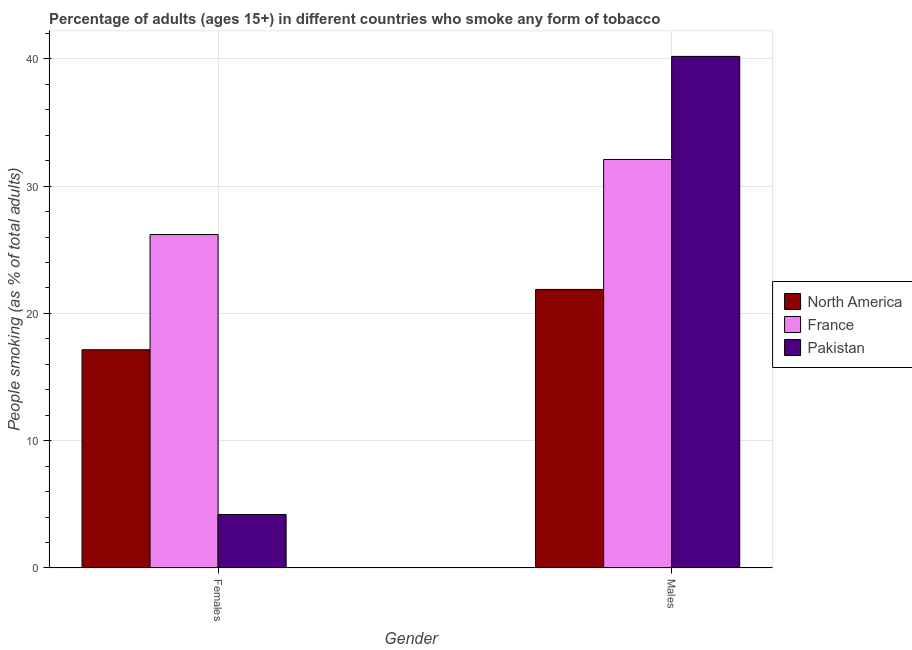How many different coloured bars are there?
Make the answer very short. 3. How many groups of bars are there?
Ensure brevity in your answer.  2. How many bars are there on the 2nd tick from the right?
Provide a succinct answer. 3. What is the label of the 2nd group of bars from the left?
Keep it short and to the point. Males. What is the percentage of males who smoke in Pakistan?
Your response must be concise. 40.2. Across all countries, what is the maximum percentage of females who smoke?
Give a very brief answer. 26.2. Across all countries, what is the minimum percentage of females who smoke?
Make the answer very short. 4.2. In which country was the percentage of males who smoke maximum?
Your response must be concise. Pakistan. In which country was the percentage of females who smoke minimum?
Offer a terse response. Pakistan. What is the total percentage of females who smoke in the graph?
Your answer should be very brief. 47.55. What is the difference between the percentage of males who smoke in France and the percentage of females who smoke in North America?
Offer a terse response. 14.95. What is the average percentage of males who smoke per country?
Give a very brief answer. 31.4. What is the difference between the percentage of females who smoke and percentage of males who smoke in North America?
Your answer should be very brief. -4.74. What is the ratio of the percentage of females who smoke in North America to that in Pakistan?
Give a very brief answer. 4.08. Is the percentage of females who smoke in France less than that in Pakistan?
Your answer should be very brief. No. What does the 1st bar from the left in Males represents?
Keep it short and to the point. North America. Are all the bars in the graph horizontal?
Provide a short and direct response. No. How many countries are there in the graph?
Offer a terse response. 3. Are the values on the major ticks of Y-axis written in scientific E-notation?
Keep it short and to the point. No. Does the graph contain any zero values?
Your response must be concise. No. How are the legend labels stacked?
Your answer should be very brief. Vertical. What is the title of the graph?
Your response must be concise. Percentage of adults (ages 15+) in different countries who smoke any form of tobacco. What is the label or title of the X-axis?
Your answer should be very brief. Gender. What is the label or title of the Y-axis?
Your answer should be very brief. People smoking (as % of total adults). What is the People smoking (as % of total adults) of North America in Females?
Keep it short and to the point. 17.15. What is the People smoking (as % of total adults) in France in Females?
Give a very brief answer. 26.2. What is the People smoking (as % of total adults) of North America in Males?
Keep it short and to the point. 21.89. What is the People smoking (as % of total adults) of France in Males?
Offer a terse response. 32.1. What is the People smoking (as % of total adults) in Pakistan in Males?
Your answer should be compact. 40.2. Across all Gender, what is the maximum People smoking (as % of total adults) of North America?
Give a very brief answer. 21.89. Across all Gender, what is the maximum People smoking (as % of total adults) in France?
Give a very brief answer. 32.1. Across all Gender, what is the maximum People smoking (as % of total adults) of Pakistan?
Ensure brevity in your answer.  40.2. Across all Gender, what is the minimum People smoking (as % of total adults) in North America?
Give a very brief answer. 17.15. Across all Gender, what is the minimum People smoking (as % of total adults) of France?
Offer a very short reply. 26.2. Across all Gender, what is the minimum People smoking (as % of total adults) of Pakistan?
Ensure brevity in your answer.  4.2. What is the total People smoking (as % of total adults) in North America in the graph?
Provide a succinct answer. 39.04. What is the total People smoking (as % of total adults) of France in the graph?
Make the answer very short. 58.3. What is the total People smoking (as % of total adults) of Pakistan in the graph?
Ensure brevity in your answer.  44.4. What is the difference between the People smoking (as % of total adults) of North America in Females and that in Males?
Offer a very short reply. -4.74. What is the difference between the People smoking (as % of total adults) in France in Females and that in Males?
Offer a terse response. -5.9. What is the difference between the People smoking (as % of total adults) in Pakistan in Females and that in Males?
Ensure brevity in your answer.  -36. What is the difference between the People smoking (as % of total adults) of North America in Females and the People smoking (as % of total adults) of France in Males?
Provide a short and direct response. -14.95. What is the difference between the People smoking (as % of total adults) in North America in Females and the People smoking (as % of total adults) in Pakistan in Males?
Offer a terse response. -23.05. What is the difference between the People smoking (as % of total adults) of France in Females and the People smoking (as % of total adults) of Pakistan in Males?
Ensure brevity in your answer.  -14. What is the average People smoking (as % of total adults) in North America per Gender?
Your response must be concise. 19.52. What is the average People smoking (as % of total adults) in France per Gender?
Keep it short and to the point. 29.15. What is the difference between the People smoking (as % of total adults) in North America and People smoking (as % of total adults) in France in Females?
Your answer should be very brief. -9.05. What is the difference between the People smoking (as % of total adults) of North America and People smoking (as % of total adults) of Pakistan in Females?
Make the answer very short. 12.95. What is the difference between the People smoking (as % of total adults) of North America and People smoking (as % of total adults) of France in Males?
Your answer should be compact. -10.21. What is the difference between the People smoking (as % of total adults) of North America and People smoking (as % of total adults) of Pakistan in Males?
Make the answer very short. -18.31. What is the ratio of the People smoking (as % of total adults) of North America in Females to that in Males?
Your answer should be very brief. 0.78. What is the ratio of the People smoking (as % of total adults) of France in Females to that in Males?
Provide a succinct answer. 0.82. What is the ratio of the People smoking (as % of total adults) of Pakistan in Females to that in Males?
Provide a short and direct response. 0.1. What is the difference between the highest and the second highest People smoking (as % of total adults) of North America?
Keep it short and to the point. 4.74. What is the difference between the highest and the lowest People smoking (as % of total adults) in North America?
Your answer should be very brief. 4.74. What is the difference between the highest and the lowest People smoking (as % of total adults) of Pakistan?
Your answer should be compact. 36. 